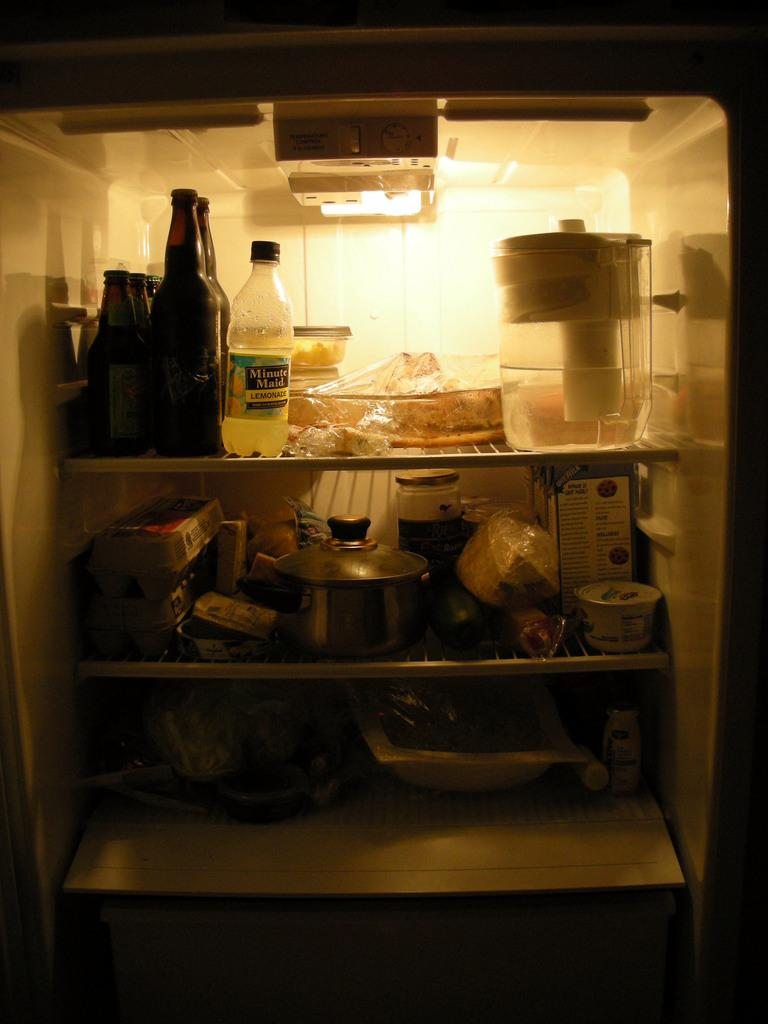<image>
Create a compact narrative representing the image presented. A bottle of Minute Maid sits on the top shelf of a crowded refrigerator. 